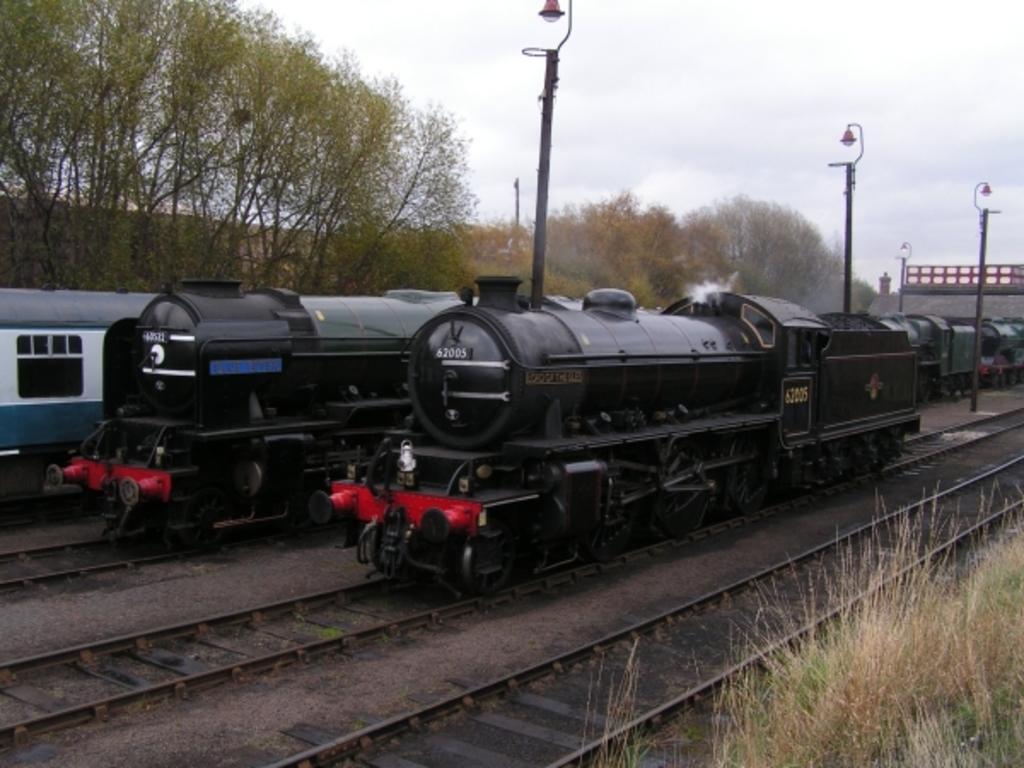Please provide a concise description of this image. In the picture I can see trains on railway tracks. In the background I can see trees, the grass, railway tracks, the sky, street lights and some other objects. 